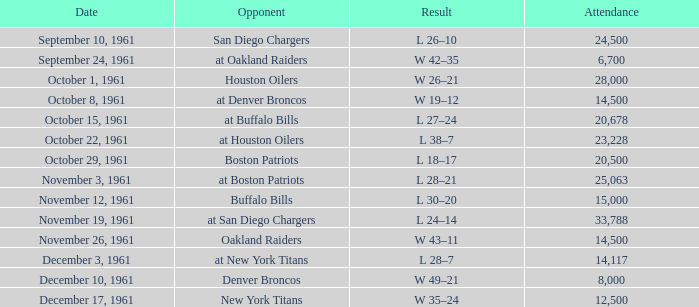Help me parse the entirety of this table. {'header': ['Date', 'Opponent', 'Result', 'Attendance'], 'rows': [['September 10, 1961', 'San Diego Chargers', 'L 26–10', '24,500'], ['September 24, 1961', 'at Oakland Raiders', 'W 42–35', '6,700'], ['October 1, 1961', 'Houston Oilers', 'W 26–21', '28,000'], ['October 8, 1961', 'at Denver Broncos', 'W 19–12', '14,500'], ['October 15, 1961', 'at Buffalo Bills', 'L 27–24', '20,678'], ['October 22, 1961', 'at Houston Oilers', 'L 38–7', '23,228'], ['October 29, 1961', 'Boston Patriots', 'L 18–17', '20,500'], ['November 3, 1961', 'at Boston Patriots', 'L 28–21', '25,063'], ['November 12, 1961', 'Buffalo Bills', 'L 30–20', '15,000'], ['November 19, 1961', 'at San Diego Chargers', 'L 24–14', '33,788'], ['November 26, 1961', 'Oakland Raiders', 'W 43–11', '14,500'], ['December 3, 1961', 'at New York Titans', 'L 28–7', '14,117'], ['December 10, 1961', 'Denver Broncos', 'W 49–21', '8,000'], ['December 17, 1961', 'New York Titans', 'W 35–24', '12,500']]} What is the least week from october 15, 1961? 5.0. 